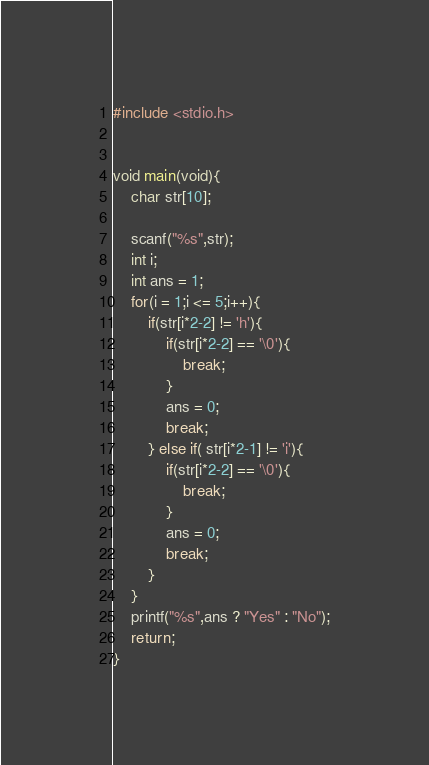<code> <loc_0><loc_0><loc_500><loc_500><_C_>#include <stdio.h>


void main(void){
    char str[10];

    scanf("%s",str);
    int i;
    int ans = 1;
    for(i = 1;i <= 5;i++){
        if(str[i*2-2] != 'h'){
            if(str[i*2-2] == '\0'){
                break;
            }
            ans = 0;
            break;
        } else if( str[i*2-1] != 'i'){
            if(str[i*2-2] == '\0'){
                break;
            }
            ans = 0;
            break;
        }
    }
    printf("%s",ans ? "Yes" : "No");
    return;
}</code> 